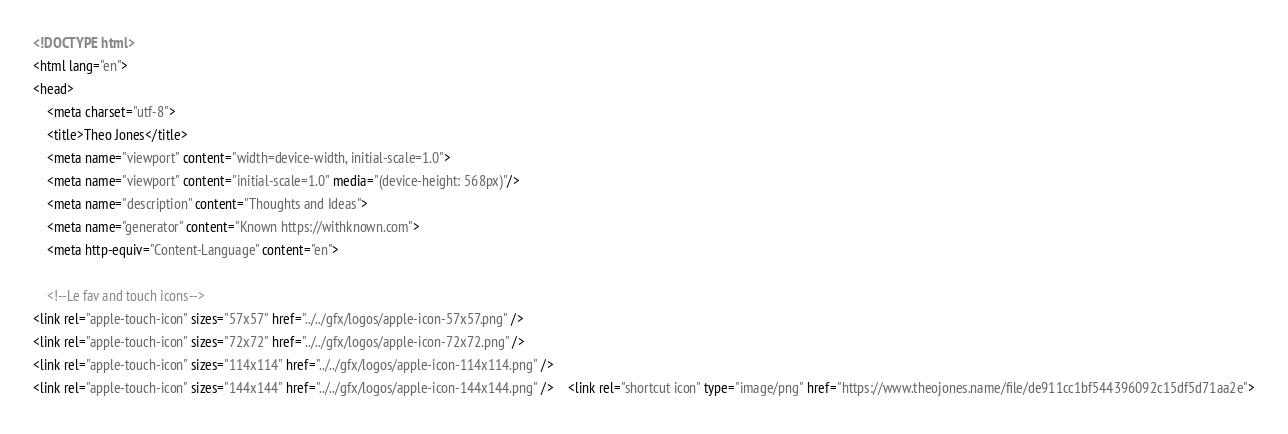<code> <loc_0><loc_0><loc_500><loc_500><_HTML_><!DOCTYPE html>
<html lang="en">
<head>
    <meta charset="utf-8">
    <title>Theo Jones</title>
    <meta name="viewport" content="width=device-width, initial-scale=1.0">
    <meta name="viewport" content="initial-scale=1.0" media="(device-height: 568px)"/>
    <meta name="description" content="Thoughts and Ideas">
    <meta name="generator" content="Known https://withknown.com">
    <meta http-equiv="Content-Language" content="en">

    <!--Le fav and touch icons-->
<link rel="apple-touch-icon" sizes="57x57" href="../../gfx/logos/apple-icon-57x57.png" />
<link rel="apple-touch-icon" sizes="72x72" href="../../gfx/logos/apple-icon-72x72.png" />
<link rel="apple-touch-icon" sizes="114x114" href="../../gfx/logos/apple-icon-114x114.png" />
<link rel="apple-touch-icon" sizes="144x144" href="../../gfx/logos/apple-icon-144x144.png" />    <link rel="shortcut icon" type="image/png" href="https://www.theojones.name/file/de911cc1bf544396092c15df5d71aa2e"></code> 